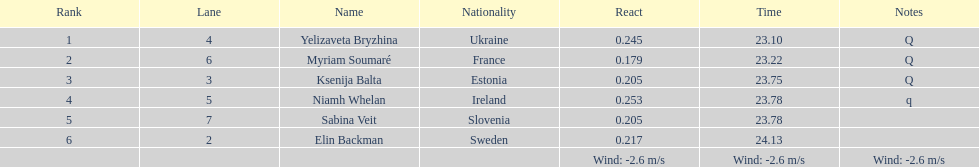Parse the full table. {'header': ['Rank', 'Lane', 'Name', 'Nationality', 'React', 'Time', 'Notes'], 'rows': [['1', '4', 'Yelizaveta Bryzhina', 'Ukraine', '0.245', '23.10', 'Q'], ['2', '6', 'Myriam Soumaré', 'France', '0.179', '23.22', 'Q'], ['3', '3', 'Ksenija Balta', 'Estonia', '0.205', '23.75', 'Q'], ['4', '5', 'Niamh Whelan', 'Ireland', '0.253', '23.78', 'q'], ['5', '7', 'Sabina Veit', 'Slovenia', '0.205', '23.78', ''], ['6', '2', 'Elin Backman', 'Sweden', '0.217', '24.13', ''], ['', '', '', '', 'Wind: -2.6\xa0m/s', 'Wind: -2.6\xa0m/s', 'Wind: -2.6\xa0m/s']]} Who is the female athlete that secured the top position in heat 1 of the women's 200 meters? Yelizaveta Bryzhina. 